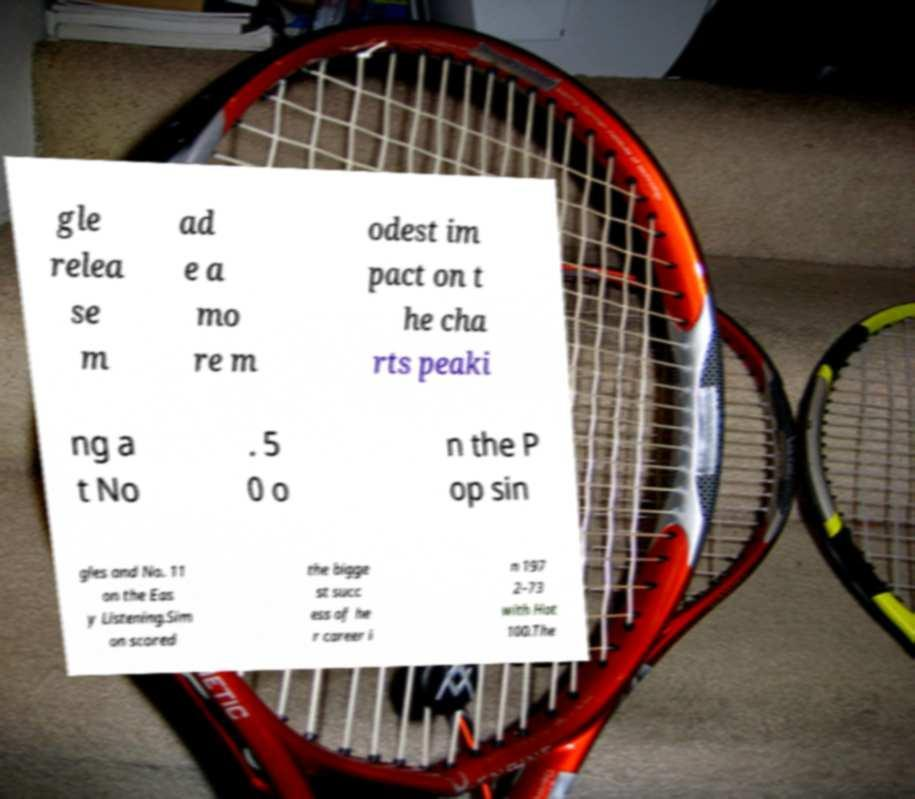Please read and relay the text visible in this image. What does it say? gle relea se m ad e a mo re m odest im pact on t he cha rts peaki ng a t No . 5 0 o n the P op sin gles and No. 11 on the Eas y Listening.Sim on scored the bigge st succ ess of he r career i n 197 2–73 with Hot 100.The 